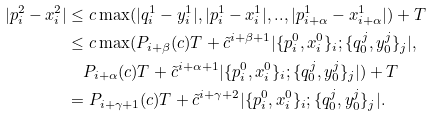Convert formula to latex. <formula><loc_0><loc_0><loc_500><loc_500>| p _ { i } ^ { 2 } - x _ { i } ^ { 2 } | & \leq c \max ( | q _ { i } ^ { 1 } - y _ { i } ^ { 1 } | , | p _ { i } ^ { 1 } - x _ { i } ^ { 1 } | , . . , | p _ { i + \alpha } ^ { 1 } - x _ { i + \alpha } ^ { 1 } | ) + T \\ & \leq c \max ( P _ { i + \beta } ( c ) T + \tilde { c } ^ { i + \beta + 1 } | \{ p _ { i } ^ { 0 } , x _ { i } ^ { 0 } \} _ { i } ; \{ q ^ { j } _ { 0 } , y ^ { j } _ { 0 } \} _ { j } | , \\ & \quad P _ { i + \alpha } ( c ) T + \tilde { c } ^ { i + \alpha + 1 } | \{ p _ { i } ^ { 0 } , x _ { i } ^ { 0 } \} _ { i } ; \{ q ^ { j } _ { 0 } , y ^ { j } _ { 0 } \} _ { j } | ) + T \\ & = P _ { i + \gamma + 1 } ( c ) T + \tilde { c } ^ { i + \gamma + 2 } | \{ p _ { i } ^ { 0 } , x _ { i } ^ { 0 } \} _ { i } ; \{ q ^ { j } _ { 0 } , y ^ { j } _ { 0 } \} _ { j } | .</formula> 